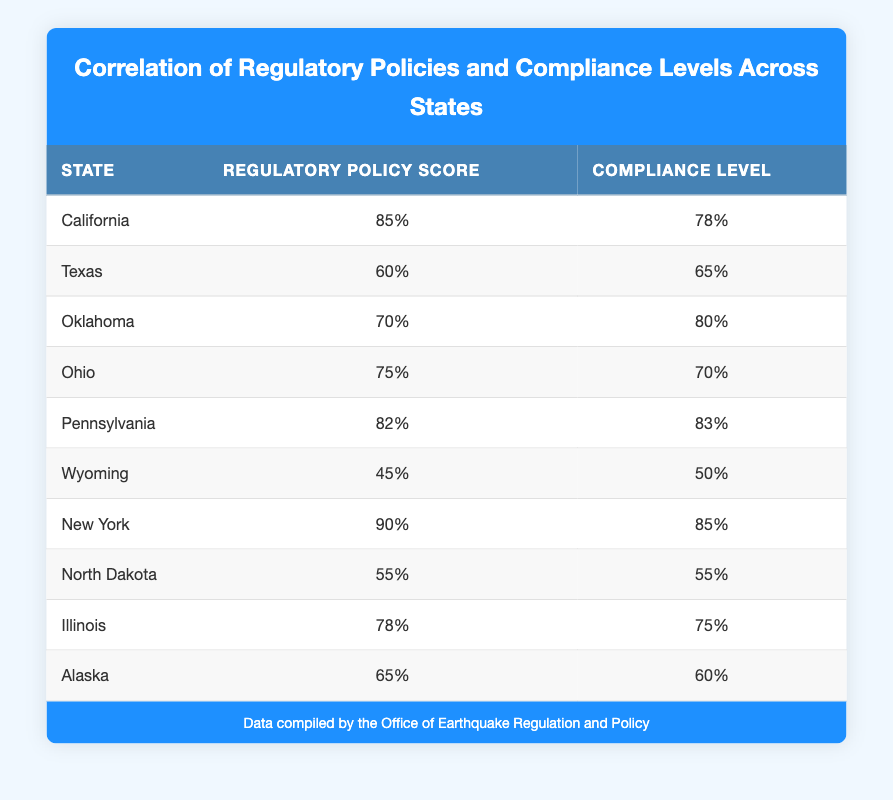What is the regulatory policy score of New York? From the table, New York has a regulatory policy score listed as 90.
Answer: 90 Which state has the highest compliance level? Looking at the compliance levels, Pennsylvania has the highest score at 83.
Answer: Pennsylvania Is the compliance level of Texas higher than that of California? Texas has a compliance level of 65, while California's is 78, which means Texas's compliance level is not higher.
Answer: No What is the average regulatory policy score of the states listed? To find the average: (85 + 60 + 70 + 75 + 82 + 45 + 90 + 55 + 78 + 65) = 75, with 10 states in total, so the average is 750/10 = 75.
Answer: 75 Which state has a compliance level that is exactly equal to its regulatory policy score? North Dakota has a compliance level of 55, which is the same as its regulatory policy score of 55.
Answer: North Dakota What is the difference between the highest and lowest regulatory policy scores among the states? The highest score is 90 (New York) and the lowest is 45 (Wyoming). The difference is 90 - 45 = 45.
Answer: 45 Are the compliance levels of states with a regulatory policy score above 80 generally higher than those below? For scores above 80 (California, Pennsylvania, New York), the compliance levels are 78, 83, and 85. For scores below 80 (Texas, Oklahoma, Ohio, Wyoming, North Dakota, Alaska, Illinois), the compliance levels average to 66.57 (65, 80, 70, 50, 55, 60, 75). Yes, the higher score states have higher compliance levels.
Answer: Yes What is the regulatory policy score for the states that have a compliance level of 80 or above? The states with compliance levels of 80 or above are Oklahoma (70), Pennsylvania (82), New York (90). Their regulatory scores are 70, 82, and 90, respectively.
Answer: 70, 82, 90 Which state has the lowest compliance level and what is its regulatory policy score? Wyoming has the lowest compliance level of 50 and its regulatory policy score is 45.
Answer: Wyoming, 45 